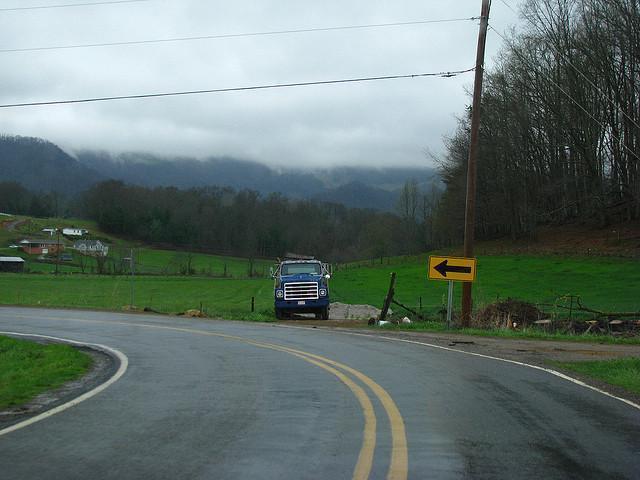How many arrows can you see?
Give a very brief answer. 1. How many women on bikes are in the picture?
Give a very brief answer. 0. 